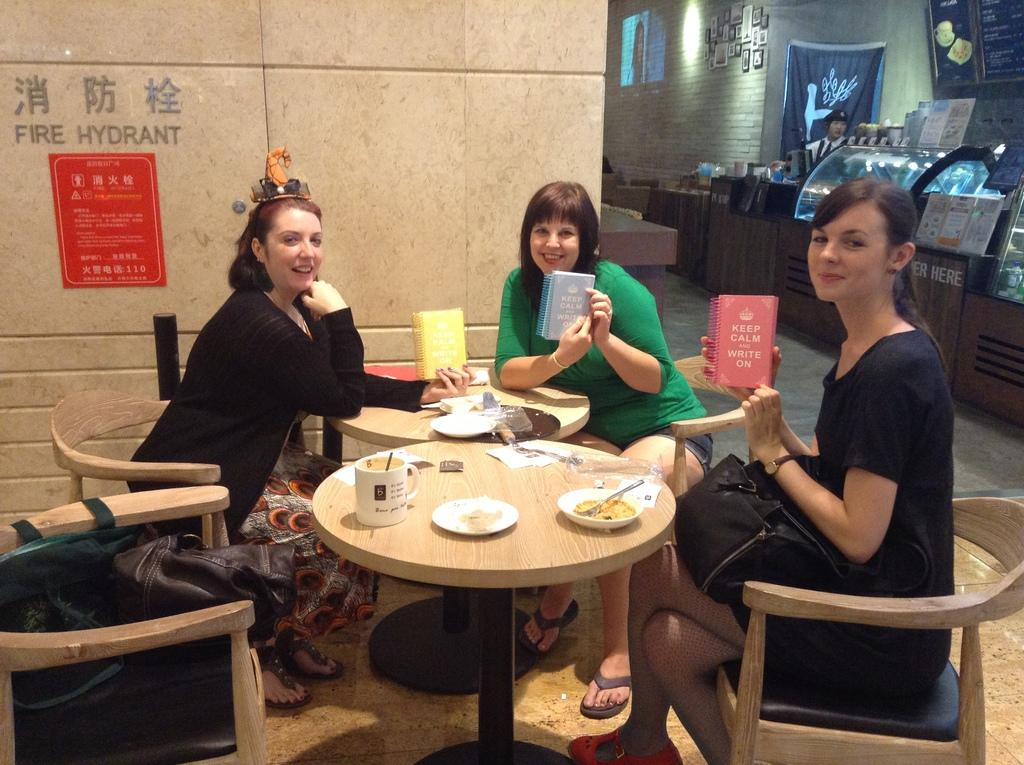Who is present in the image? There are women in the image. What are the women doing in the image? The women are seated on chairs. What objects are the women holding in the image? The women are holding books in their hands. What type of trail can be seen in the image? There is no trail present in the image; it features women seated on chairs holding books. 